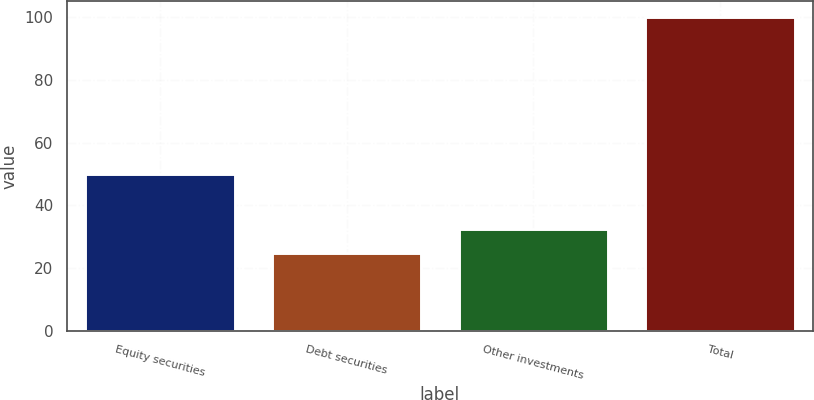Convert chart to OTSL. <chart><loc_0><loc_0><loc_500><loc_500><bar_chart><fcel>Equity securities<fcel>Debt securities<fcel>Other investments<fcel>Total<nl><fcel>50<fcel>25<fcel>32.5<fcel>100<nl></chart> 